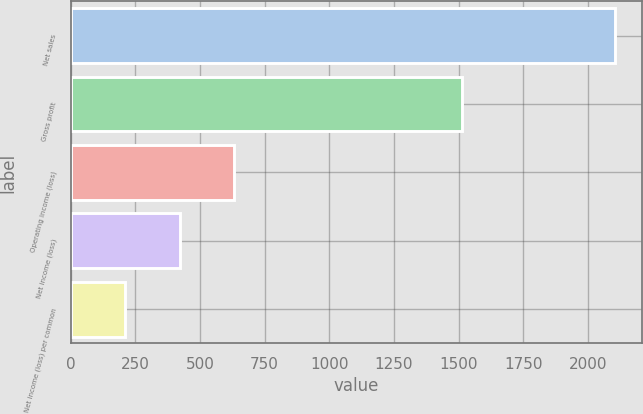<chart> <loc_0><loc_0><loc_500><loc_500><bar_chart><fcel>Net sales<fcel>Gross profit<fcel>Operating income (loss)<fcel>Net income (loss)<fcel>Net income (loss) per common<nl><fcel>2105<fcel>1511<fcel>631.61<fcel>421.13<fcel>210.65<nl></chart> 